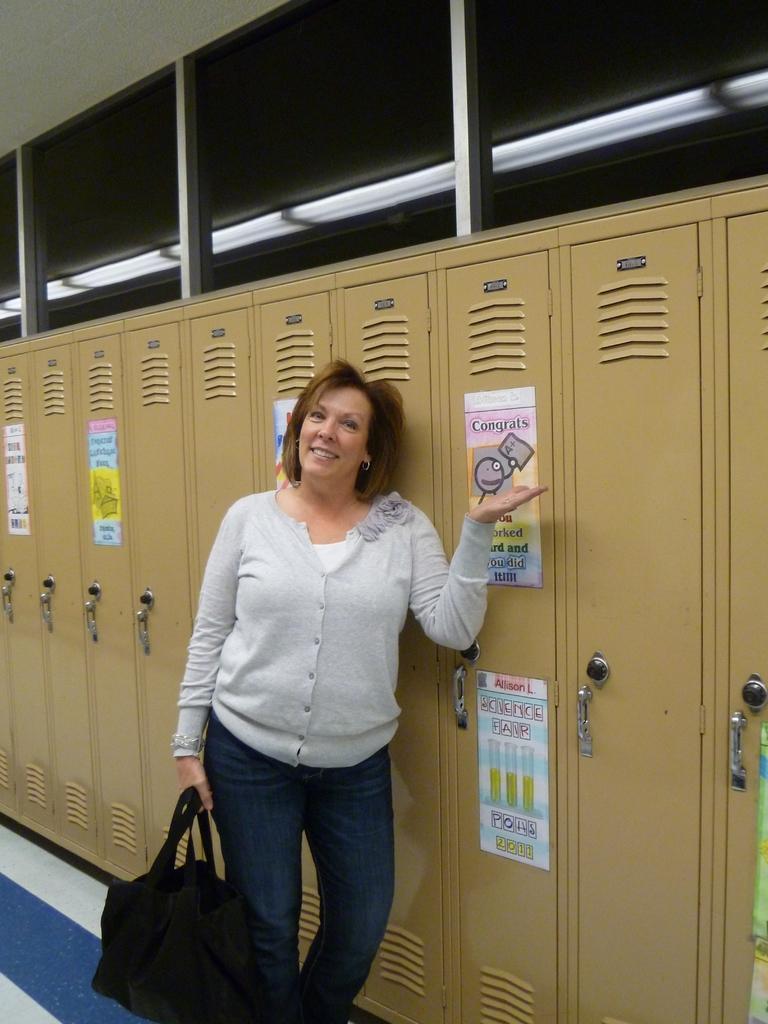Can you describe this image briefly? This picture shows a woman standing and holding a bag in her hand and we see cupboards on the side and posters on the cupboard 